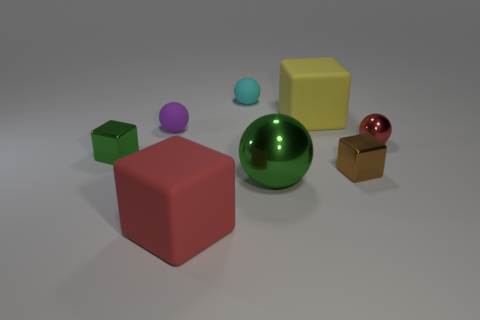How many red things are both in front of the green sphere and to the right of the small brown object?
Ensure brevity in your answer.  0. What number of other objects are there of the same size as the green metallic cube?
Provide a short and direct response. 4. What is the block that is both left of the green shiny sphere and behind the large red thing made of?
Provide a succinct answer. Metal. There is a big metal thing; does it have the same color as the tiny metallic cube that is on the left side of the big metal sphere?
Offer a terse response. Yes. The yellow matte object that is the same shape as the tiny green object is what size?
Offer a very short reply. Large. There is a matte object that is in front of the big yellow matte cube and behind the red rubber object; what is its shape?
Your answer should be compact. Sphere. There is a brown thing; does it have the same size as the metallic ball that is to the left of the large yellow rubber block?
Offer a terse response. No. There is a large object that is the same shape as the tiny red shiny object; what color is it?
Keep it short and to the point. Green. Does the metallic sphere that is on the left side of the small red metal ball have the same size as the matte cube left of the big yellow rubber thing?
Your response must be concise. Yes. Is the big green thing the same shape as the small purple thing?
Your response must be concise. Yes. 